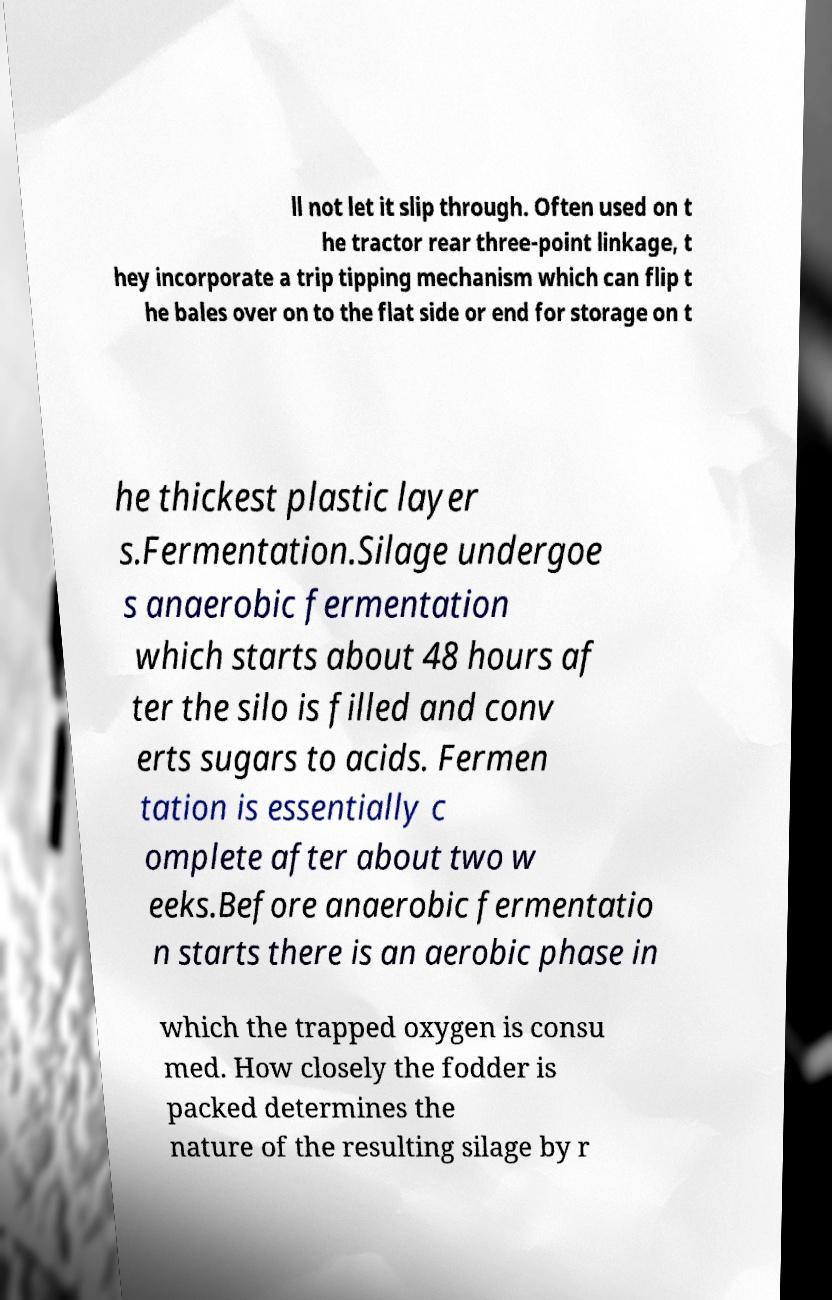For documentation purposes, I need the text within this image transcribed. Could you provide that? ll not let it slip through. Often used on t he tractor rear three-point linkage, t hey incorporate a trip tipping mechanism which can flip t he bales over on to the flat side or end for storage on t he thickest plastic layer s.Fermentation.Silage undergoe s anaerobic fermentation which starts about 48 hours af ter the silo is filled and conv erts sugars to acids. Fermen tation is essentially c omplete after about two w eeks.Before anaerobic fermentatio n starts there is an aerobic phase in which the trapped oxygen is consu med. How closely the fodder is packed determines the nature of the resulting silage by r 